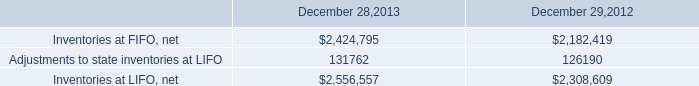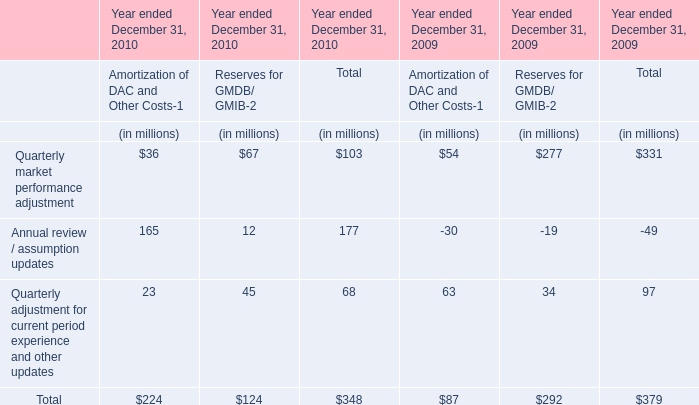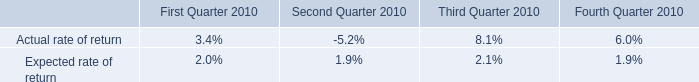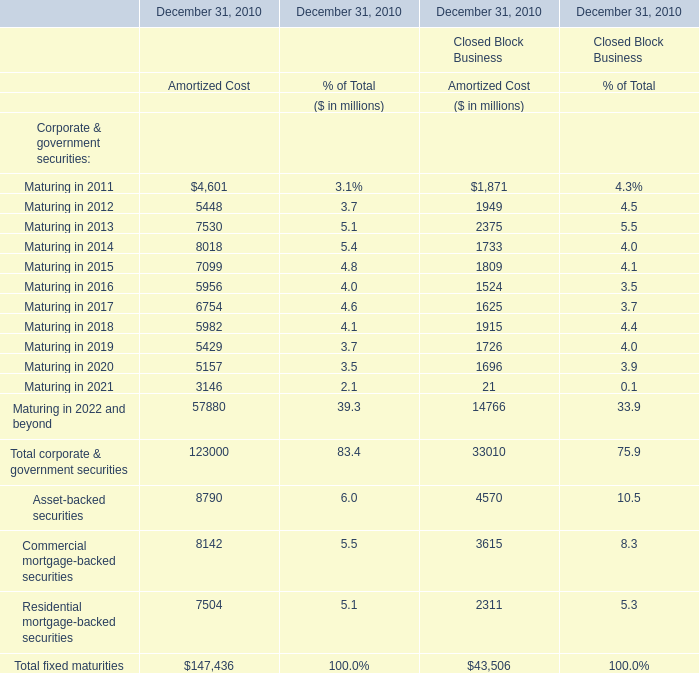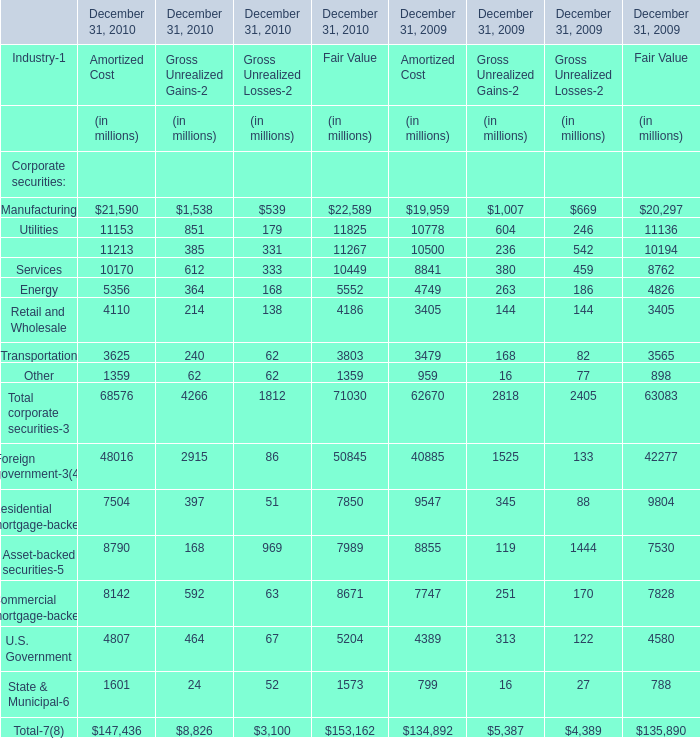Which year is Utilities for Fair Value greater than 11800? 
Answer: 2010. 